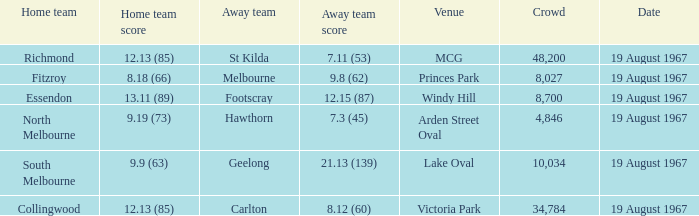When the away team scored 7.11 (53) what venue did they play at? MCG. 